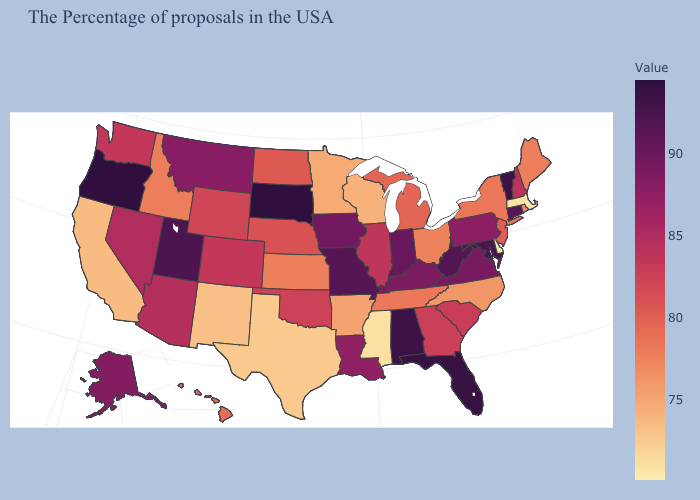Does Delaware have a higher value than Nevada?
Be succinct. No. Is the legend a continuous bar?
Answer briefly. Yes. Which states have the lowest value in the West?
Quick response, please. New Mexico. Among the states that border Rhode Island , which have the highest value?
Give a very brief answer. Connecticut. Does Rhode Island have a lower value than Arizona?
Short answer required. Yes. Which states have the lowest value in the South?
Write a very short answer. Delaware. 